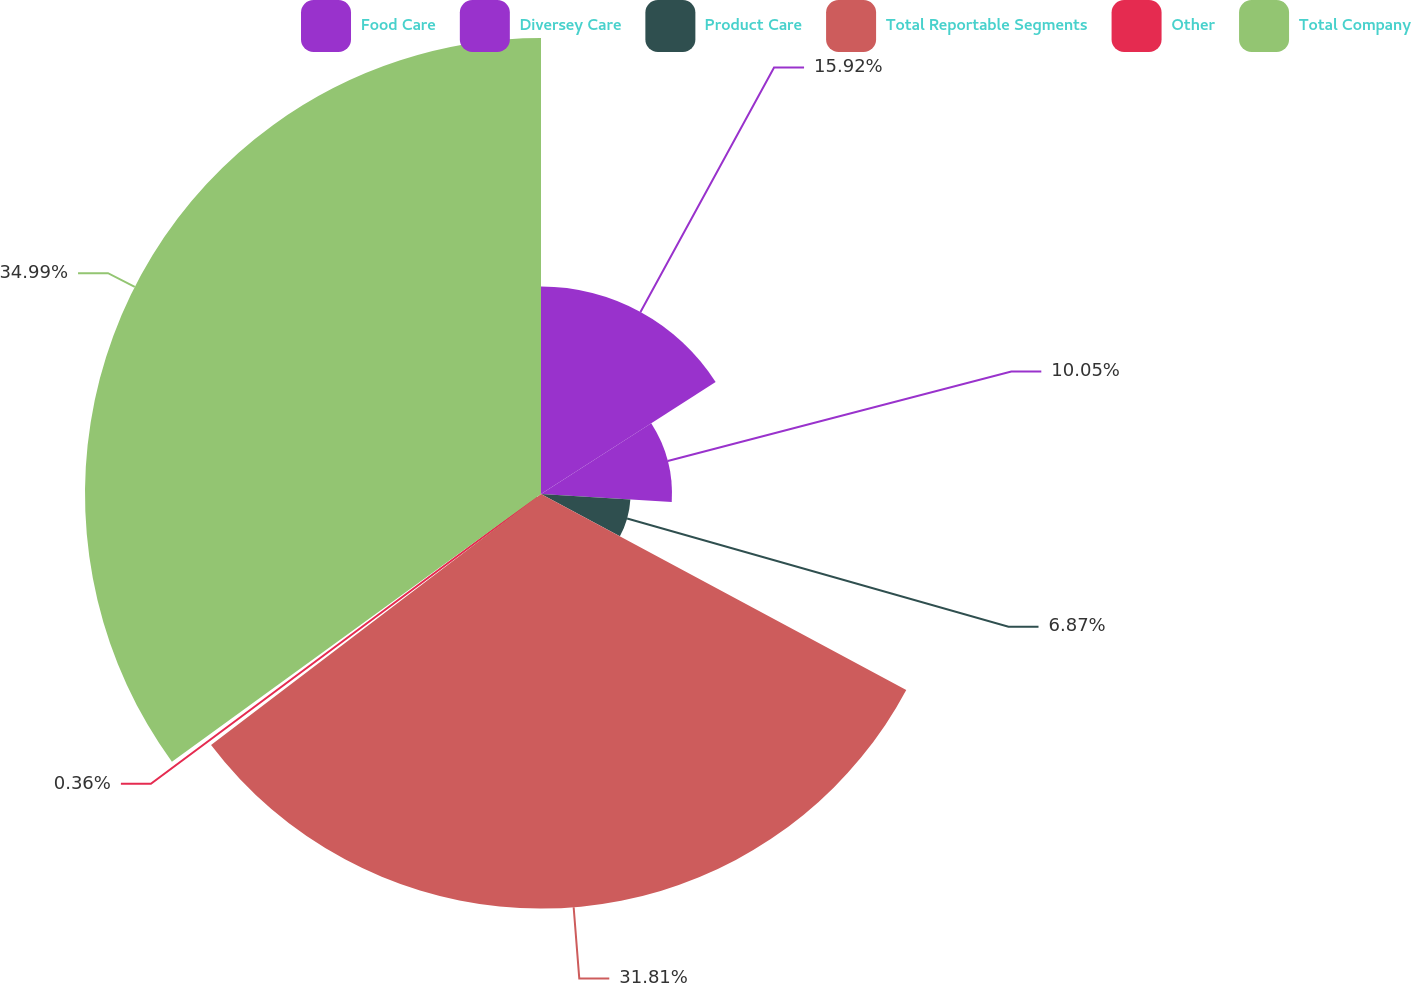<chart> <loc_0><loc_0><loc_500><loc_500><pie_chart><fcel>Food Care<fcel>Diversey Care<fcel>Product Care<fcel>Total Reportable Segments<fcel>Other<fcel>Total Company<nl><fcel>15.92%<fcel>10.05%<fcel>6.87%<fcel>31.81%<fcel>0.36%<fcel>34.99%<nl></chart> 